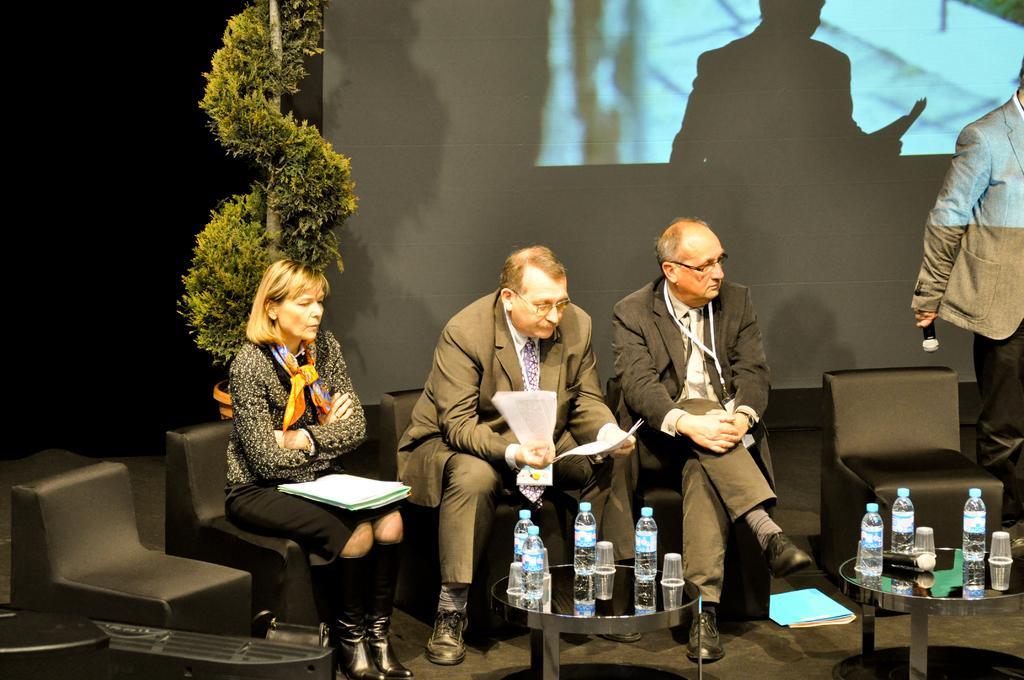Describe this image in one or two sentences. In this picture, we see three people sitting on the chairs. The man in black blazer is holding papers in his hand. In front of him, we see tables on which water bottles, glasses and a microphone are placed. On the right corner of the picture, the man in black blazer is holding a microphone in his hand. Behind him, we see a projector screen. Beside that, we see a plant. On the left corner, it is black in color. This picture is clicked in the conference hall. 